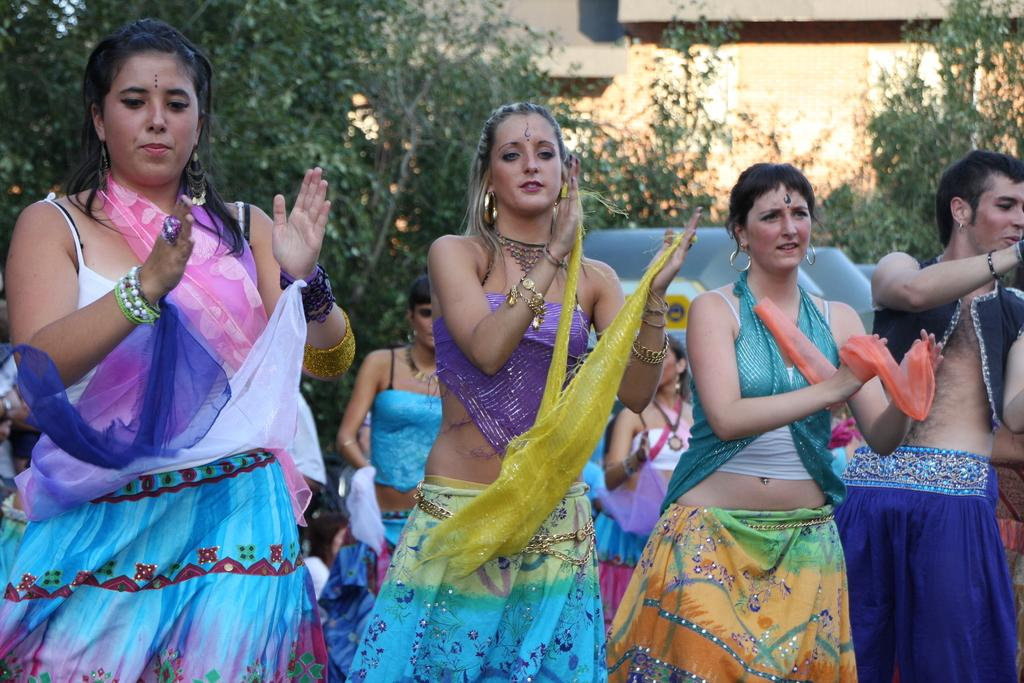What are the people in the image doing? There are people clapping in the image. What type of natural environment can be seen in the image? There are trees visible in the image. What type of structure is in the background of the image? There is a building in the background of the image. What type of tax is being discussed in the image? There is no discussion of tax in the image; it features people clapping and a background with trees and a building. 